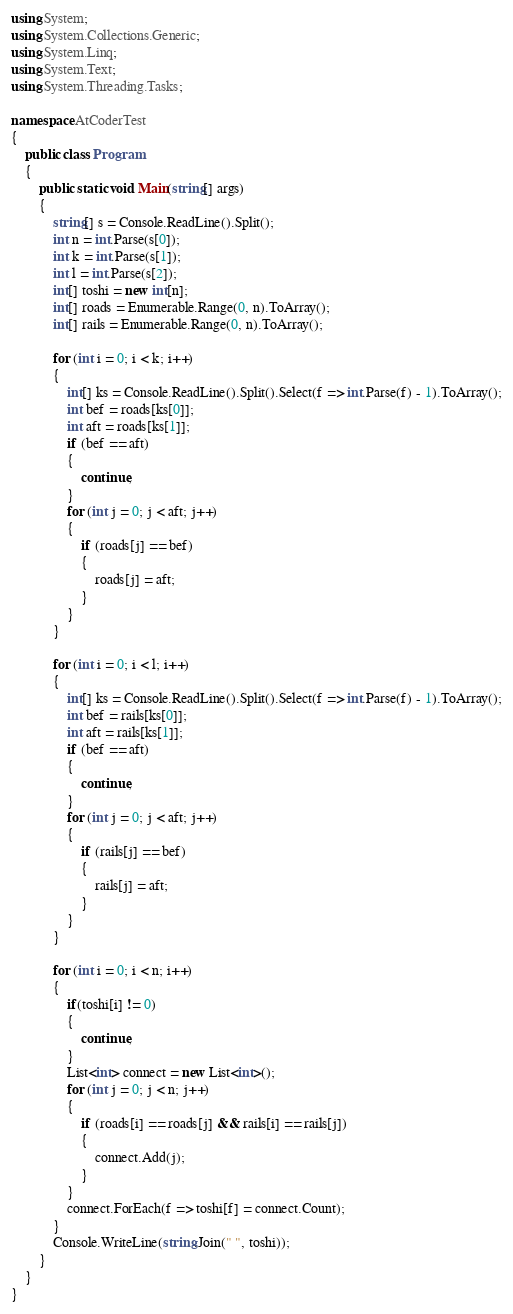<code> <loc_0><loc_0><loc_500><loc_500><_C#_>using System;
using System.Collections.Generic;
using System.Linq;
using System.Text;
using System.Threading.Tasks;

namespace AtCoderTest
{
    public class Program
    {
        public static void Main(string[] args)
        {
            string[] s = Console.ReadLine().Split();
            int n = int.Parse(s[0]);
            int k = int.Parse(s[1]);
            int l = int.Parse(s[2]);
            int[] toshi = new int[n];
            int[] roads = Enumerable.Range(0, n).ToArray();
            int[] rails = Enumerable.Range(0, n).ToArray();

            for (int i = 0; i < k; i++)
            {
                int[] ks = Console.ReadLine().Split().Select(f => int.Parse(f) - 1).ToArray();
                int bef = roads[ks[0]];
                int aft = roads[ks[1]];
                if (bef == aft)
                {
                    continue;
                }
                for (int j = 0; j < aft; j++)
                {
                    if (roads[j] == bef)
                    {
                        roads[j] = aft;
                    }
                }
            }

            for (int i = 0; i < l; i++)
            {
                int[] ks = Console.ReadLine().Split().Select(f => int.Parse(f) - 1).ToArray();
                int bef = rails[ks[0]];
                int aft = rails[ks[1]];
                if (bef == aft)
                {
                    continue;
                }
                for (int j = 0; j < aft; j++)
                {
                    if (rails[j] == bef)
                    {
                        rails[j] = aft;
                    }
                }
            }

            for (int i = 0; i < n; i++)
            {
                if(toshi[i] != 0)
                {
                    continue;
                }
                List<int> connect = new List<int>();
                for (int j = 0; j < n; j++)
                {
                    if (roads[i] == roads[j] && rails[i] == rails[j])
                    {
                        connect.Add(j);
                    }
                }
                connect.ForEach(f => toshi[f] = connect.Count);
            }
            Console.WriteLine(string.Join(" ", toshi));
        }
    }
}
</code> 